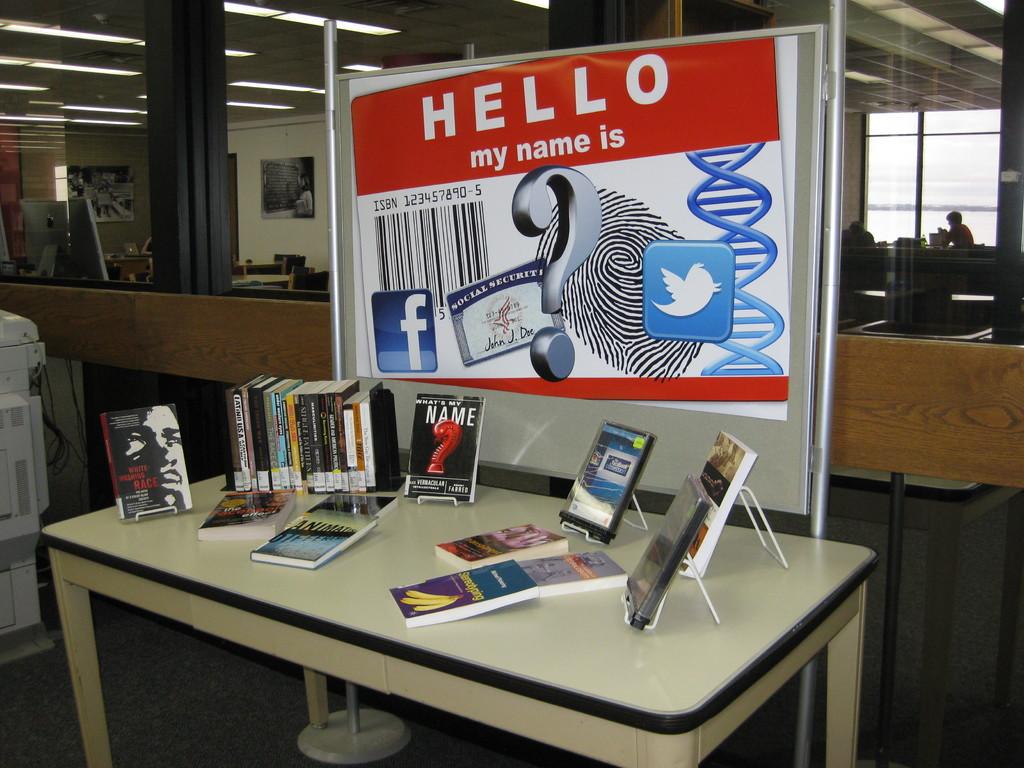Does that look like a social security card on that board?
Your response must be concise. Yes. 